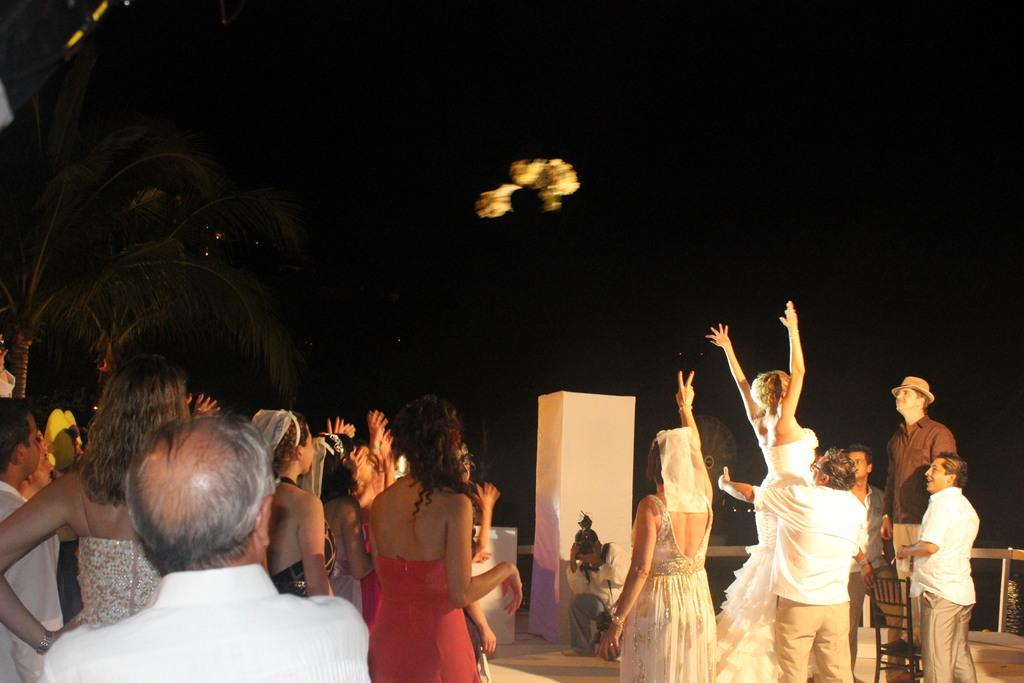How many people are in the image? There are persons standing in the image, but the exact number is not specified. What surface are the persons standing on? The persons are standing on the floor. Can you describe any furniture in the image? There is at least one chair in the image. What type of natural environment is visible in the image? Trees are present in the image. What is visible in the background of the image? The sky is visible in the image. What type of quartz can be seen in the hands of the persons in the image? There is no quartz present in the image; the persons are not holding any quartz. Can you describe the behavior of the hen in the image? There is no hen present in the image. 